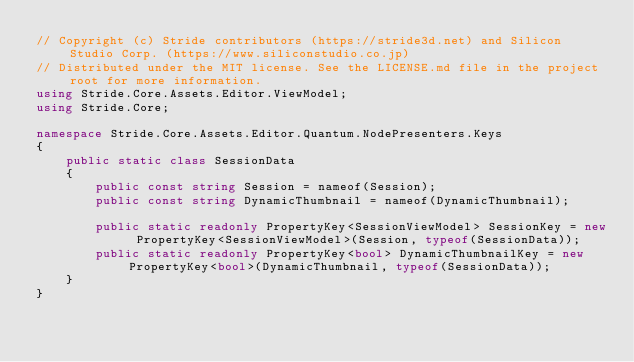<code> <loc_0><loc_0><loc_500><loc_500><_C#_>// Copyright (c) Stride contributors (https://stride3d.net) and Silicon Studio Corp. (https://www.siliconstudio.co.jp)
// Distributed under the MIT license. See the LICENSE.md file in the project root for more information.
using Stride.Core.Assets.Editor.ViewModel;
using Stride.Core;

namespace Stride.Core.Assets.Editor.Quantum.NodePresenters.Keys
{
    public static class SessionData
    {
        public const string Session = nameof(Session);
        public const string DynamicThumbnail = nameof(DynamicThumbnail);

        public static readonly PropertyKey<SessionViewModel> SessionKey = new PropertyKey<SessionViewModel>(Session, typeof(SessionData));
        public static readonly PropertyKey<bool> DynamicThumbnailKey = new PropertyKey<bool>(DynamicThumbnail, typeof(SessionData));
    }
}
</code> 